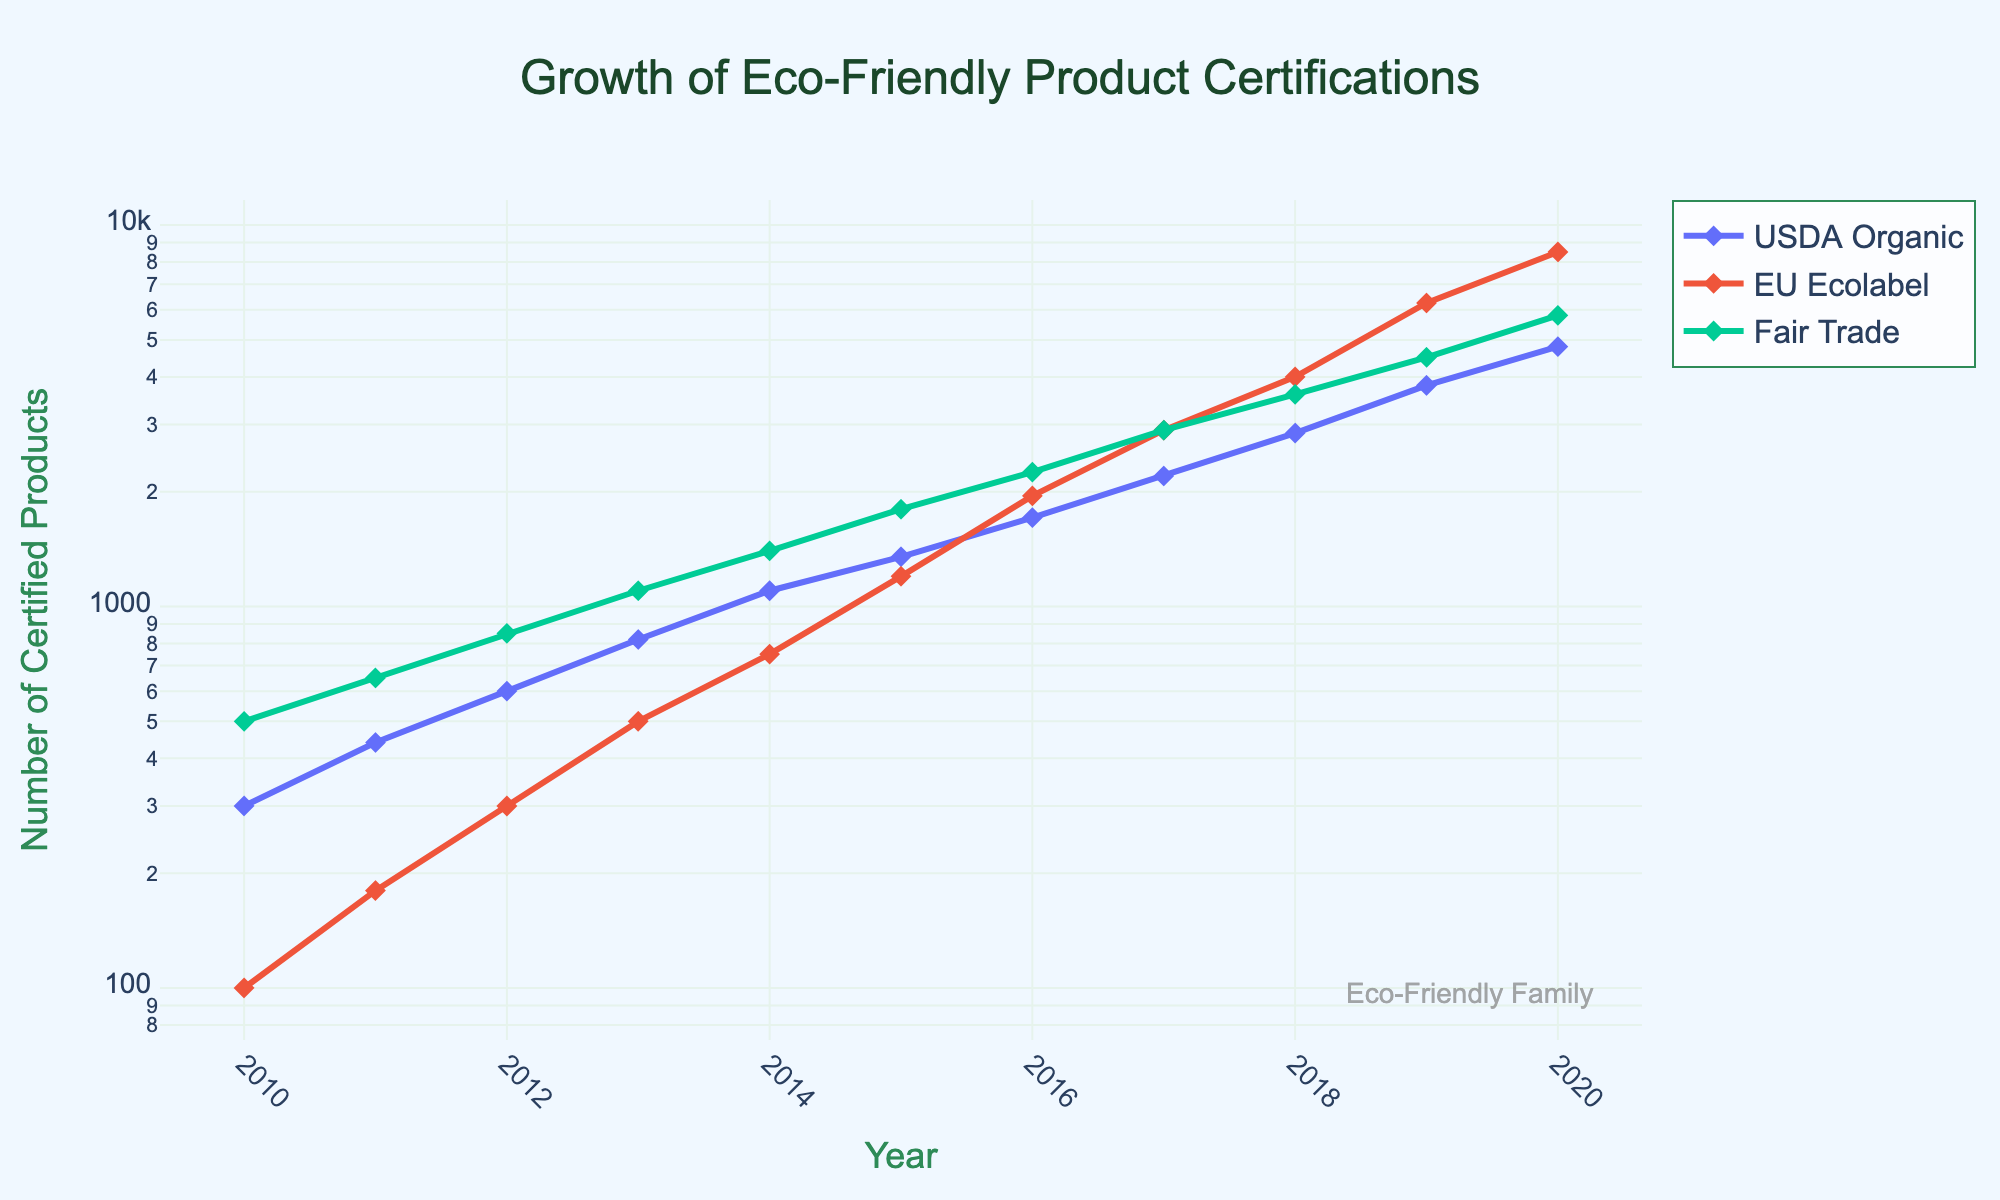Which year shows the highest number of certified products for USDA Organic? The plot displays data points for each year and the USDA Organic line has the highest value in 2020.
Answer: 2020 How do the growth rates of EU Ecolabel and Fair Trade certifications compare between 2010 and 2020? By observing the lines for both EU Ecolabel and Fair Trade, we can see that EU Ecolabel grows from 100 to 8500 products and Fair Trade grows from 500 to 5800 products, showing that EU Ecolabel has a higher growth rate.
Answer: EU Ecolabel grows faster What is the title of the plot? The title is prominently displayed at the top of the plot.
Answer: Growth of Eco-Friendly Product Certifications Which certifying agency had around 3000 certified products in 2017? By locating the year 2017 on the x-axis and finding the data point around 3000 on the y-axis (log scale), the only span line that touches this point is for Fair Trade.
Answer: Fair Trade What is the approximate number of USDA Organic certified products in 2015? We identify the year 2015 on the x-axis and follow it upward to intersect USDA Organic's line, which is at around 1350 products.
Answer: 1350 In which year did Fair Trade first surpass 2000 certified products? Locate the point where Fair Trade's line first passes 2000 on the y-axis. This happens between 2015 and 2016.
Answer: 2016 How did the total number of certified products change for USDA Organic from 2010 to 2020? Observe the starting and ending points of USDA Organic's line from 2010 to 2020. The certified products grew from 300 to 4800.
Answer: Increased by 4500 Which certification agency showed the steepest increase between consecutive years? Identify the steepest segment of the lines representing different agencies. The steepest segment is seen in EU Ecolabel from 2018 to 2019.
Answer: EU Ecolabel between 2018 and 2019 For which year does the USDA Organic certifications mark a significant change in trend? By observing the curvature and steepness at each point for USDA Organic, there is a noticeable change between 2012 and 2013 where the slope increases sharply.
Answer: 2013 